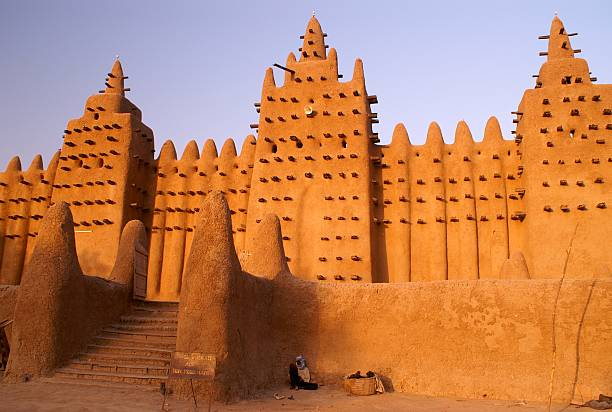What can you tell me about the historical significance of this mosque? The Great Mosque of Djenné holds immense historical significance as one of the preeminent examples of Sudano-Sahelian architecture in West Africa. Constructed in 1907 on the site of an earlier mosque, it has long served as a religious, cultural, and communal hub for the people of Djenné. The city itself was established around the 13th century, swiftly becoming a pivotal center for Islamic learning and a crucial node in the trans-Saharan trade network. The mosque is not only a place of worship but also a symbol of the knowledge and prosperity that Djenné contributed to the region. Annually, the people of Djenné partake in a festival to re-plaster the mosque's mud walls, an event that emphasizes community spirit and cultural continuity. How does the architecture of the mosque reflect the climate and environment of the region? The architecture of the Great Mosque of Djenné is a testament to the ingenuity in coping with the local climate and environmental conditions. The use of mud brick, or adobe, is well-suited to the hot, arid climate of the Sahel region. These materials are excellent for thermal regulation, keeping the interior cool during the day and warm at night. The protruding wooden beams, known as 'toron', provide support during construction and repairs but also create shadows that reduce the wall temperature. The thick walls minimize heat penetration, while the conical towers allow for natural ventilation. This architectural style ensures that the building remains functional and durable, despite the challenging climate. 